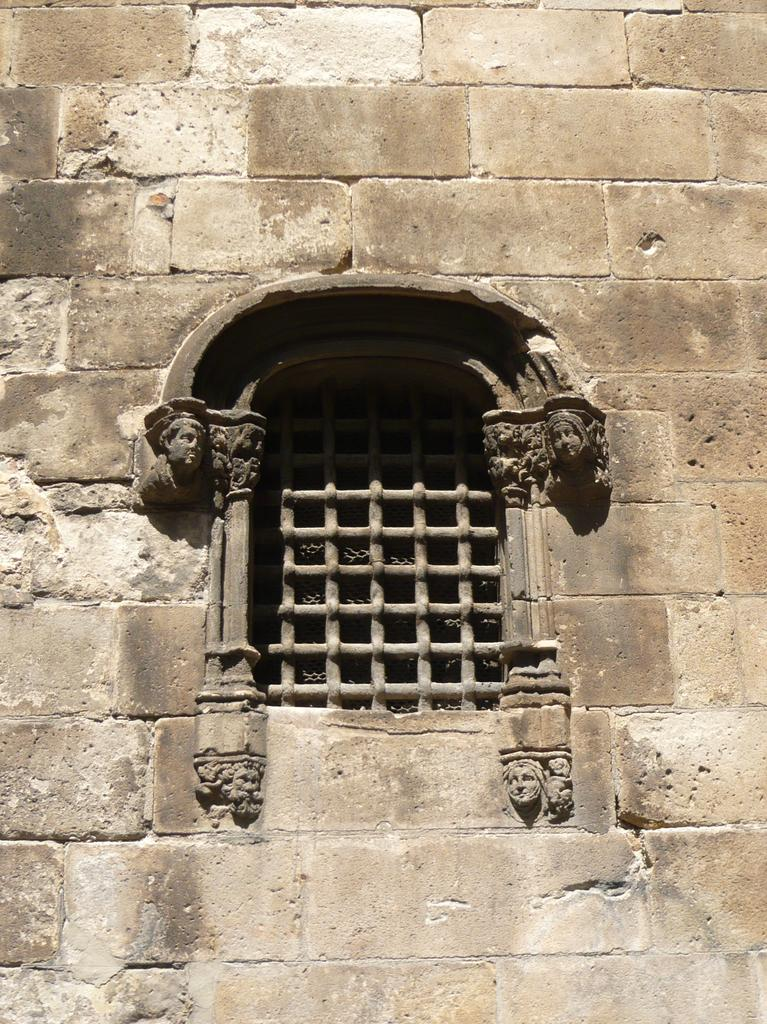What type of structure can be seen in the image? There is a wall in the image. Is there any opening in the wall visible in the image? Yes, there is a window in the image. What type of hair can be seen on the bear's head in the image? There is no bear or hair present in the image; it only features a wall and a window. 